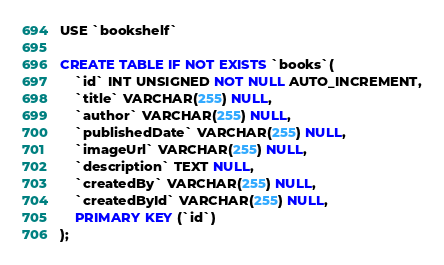<code> <loc_0><loc_0><loc_500><loc_500><_SQL_>USE `bookshelf`

CREATE TABLE IF NOT EXISTS `books`(
    `id` INT UNSIGNED NOT NULL AUTO_INCREMENT,
    `title` VARCHAR(255) NULL,
    `author` VARCHAR(255) NULL,
    `publishedDate` VARCHAR(255) NULL,
    `imageUrl` VARCHAR(255) NULL,
    `description` TEXT NULL,
    `createdBy` VARCHAR(255) NULL,
    `createdById` VARCHAR(255) NULL,
    PRIMARY KEY (`id`)
);

</code> 